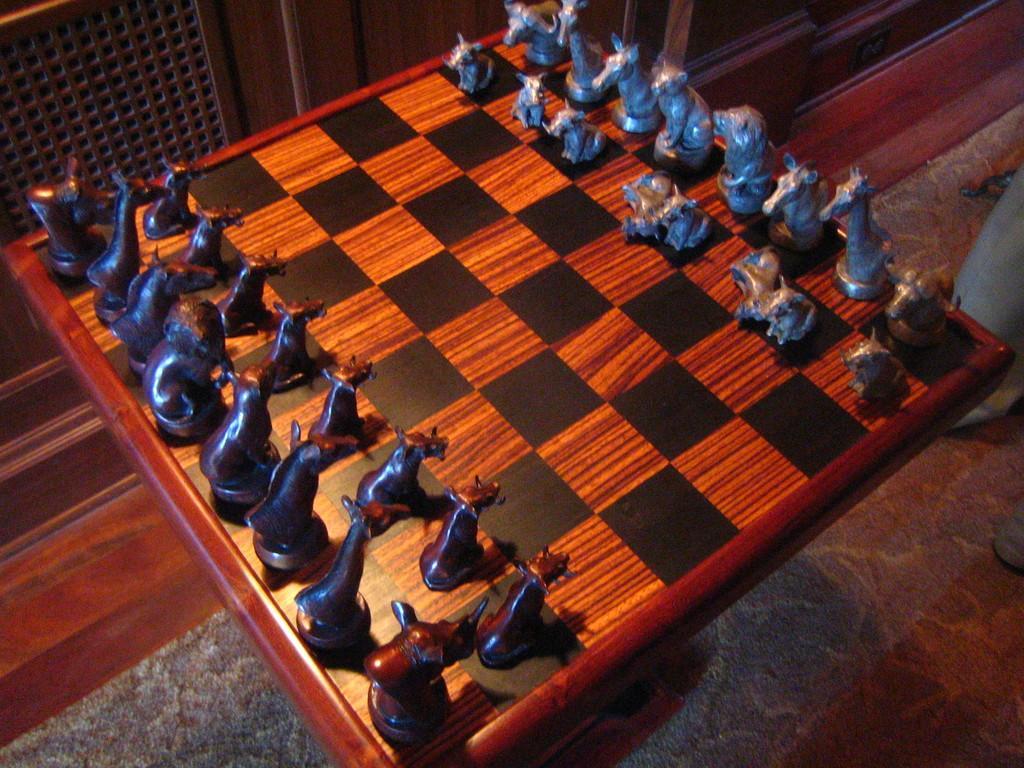Describe this image in one or two sentences. In this image we can see a chess board and chess pieces on it and the background it looks like a wall. 